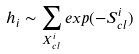Convert formula to latex. <formula><loc_0><loc_0><loc_500><loc_500>h _ { i } \sim \sum _ { X ^ { i } _ { c l } } e x p ( - S ^ { i } _ { c l } )</formula> 